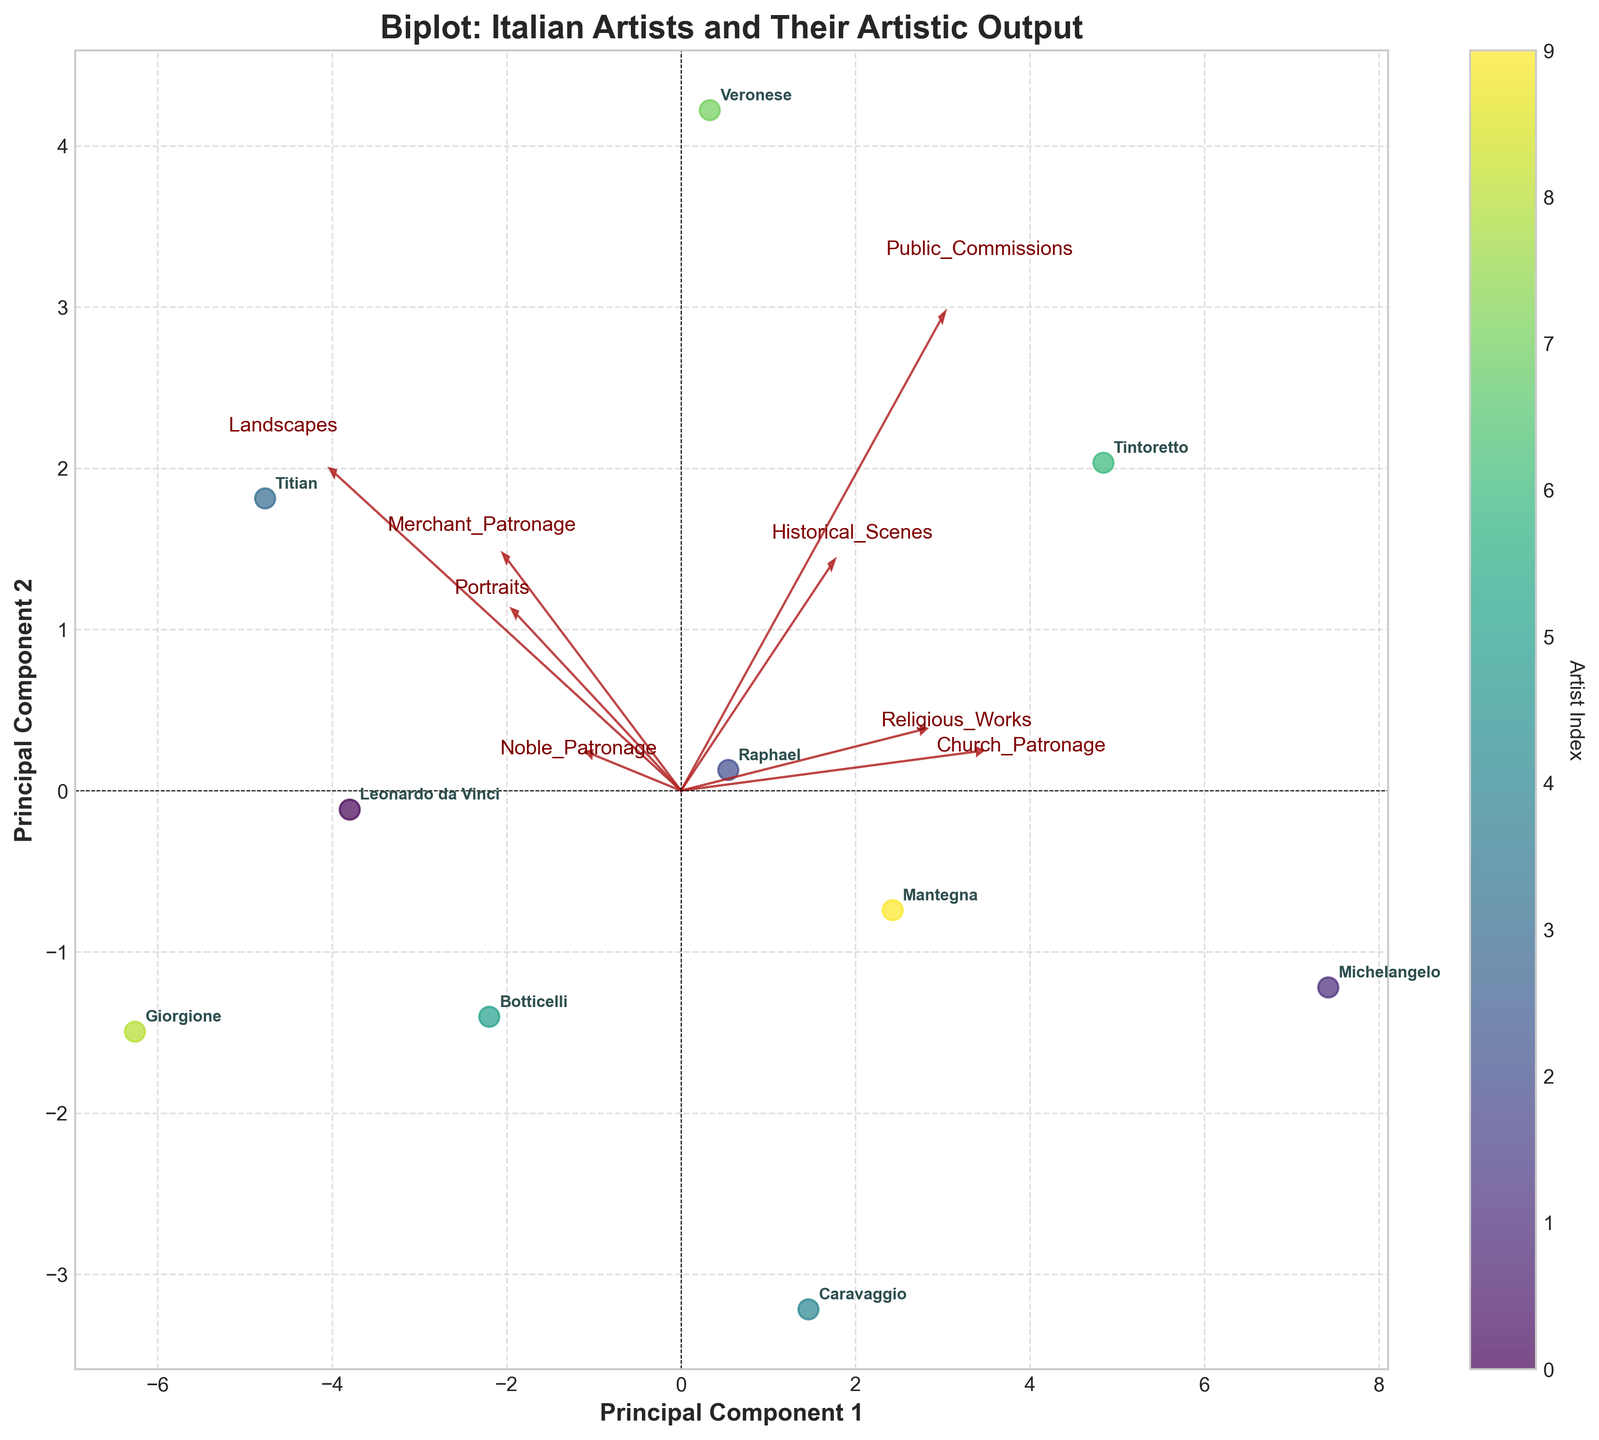What's the title of the biplot? The title of the biplot is typically displayed at the top of the plot. Look at the top center of the figure to find the title.
Answer: Biplot: Italian Artists and Their Artistic Output How many principal components are displayed on the axes? A biplot typically has two principal components displayed on its x and y axes. You can identify this by looking at the labels of the axes.
Answer: 2 Which artist is located the furthest to the right on the plot? To identify the artist located furthest to the right, look for the point with the highest value on the x-axis, and then check the annotation next to that point.
Answer: Raphael Which patronage source appears to have the highest impact on Principal Component 1 (PC1)? To determine the patronage source with the highest impact on PC1, look at the loadings corresponding to the arrows on the plot. The longer the arrow pointing towards the positive x-axis (PC1), the higher the impact.
Answer: Noble_Patronage Is there a stronger correlation between Religious_Works and Public_Commissions or between Historical_Scenes and Portraits? Compare the directions and lengths of the arrows representing these categories. Arrows that are closer in direction indicate a stronger correlation.
Answer: Religious_Works and Public_Commissions Which artists are most associated with Church_Patronage according to the biplot? Look for where the arrow for Church_Patronage is pointing and identify the artists whose points are in the same direction or close to this arrow.
Answer: Michelangelo, Raphael, Tintoretto Which type of artistic output is closely related to Noble_Patronage? Check the direction of the Noble_Patronage arrow on the biplot and find which output category arrows are pointing in the same or similar direction.
Answer: Portraits How many artists have similar outputs, considering their proximity on the biplot? Identify clusters by looking for groups of points that are close to each other. Count how many clusters and the number of points in each.
Answer: Multiple small clusters with varying artists, roughly 2-3 artists per cluster Are the works of Caravaggio more associated with Church_Patronage or Merchant_Patronage? Locate Caravaggio on the biplot and compare its position relative to the arrows for Church_Patronage and Merchant_Patronage. Closer proximity indicates a stronger association.
Answer: Church_Patronage Which two patronage sources are least correlated with each other? Look at the angles between arrows representing patronage sources. Arrows that are nearly perpendicular to each other indicate the least correlation.
Answer: Church_Patronage and Merchant_Patronage 